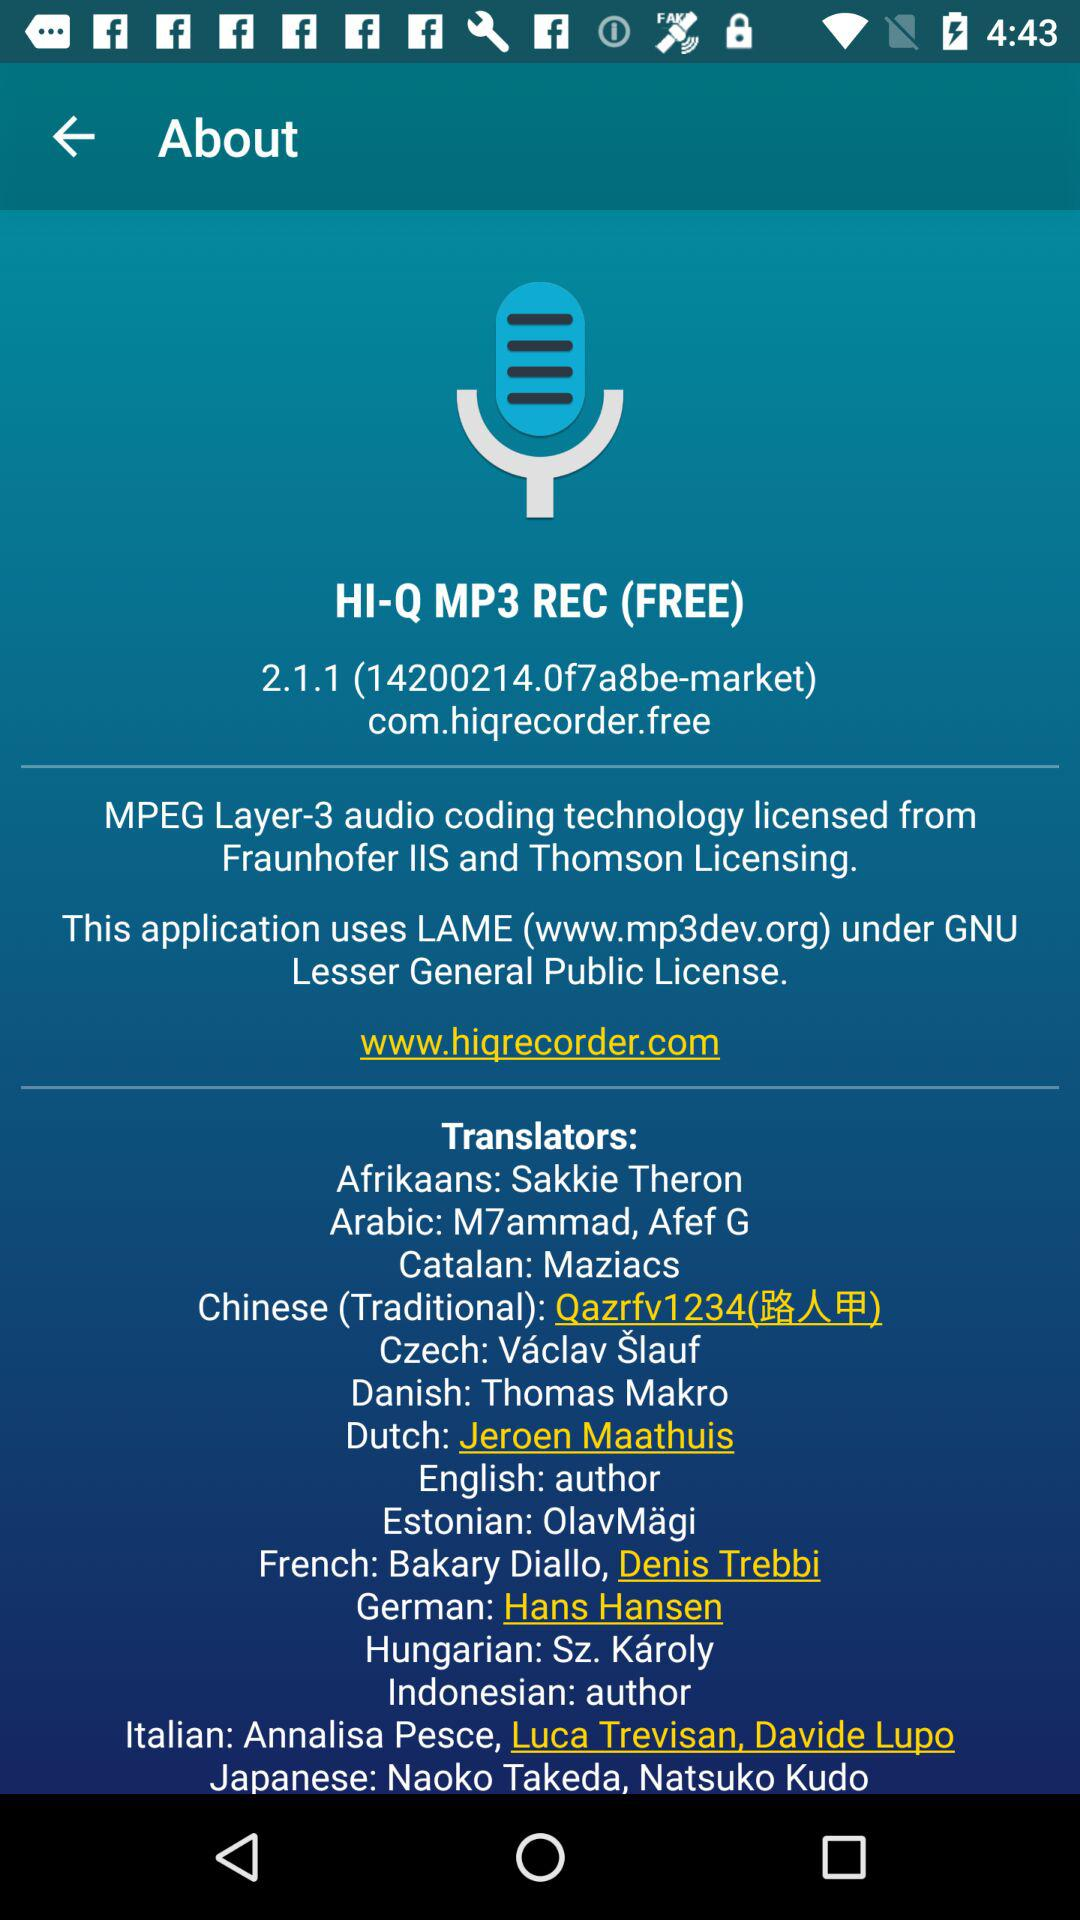Who is the translator of English? The translator of English is the author. 